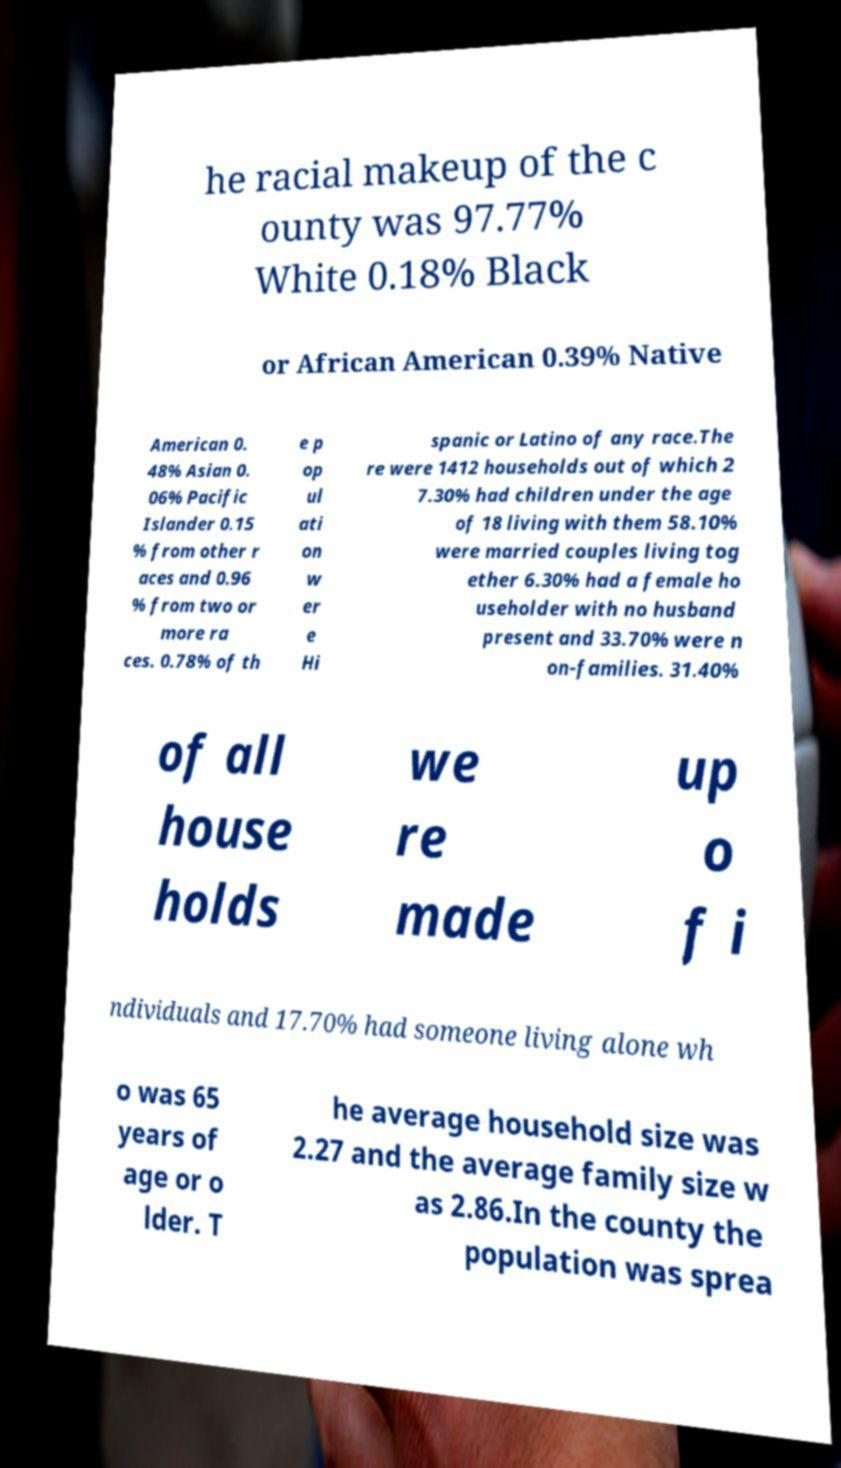Can you accurately transcribe the text from the provided image for me? he racial makeup of the c ounty was 97.77% White 0.18% Black or African American 0.39% Native American 0. 48% Asian 0. 06% Pacific Islander 0.15 % from other r aces and 0.96 % from two or more ra ces. 0.78% of th e p op ul ati on w er e Hi spanic or Latino of any race.The re were 1412 households out of which 2 7.30% had children under the age of 18 living with them 58.10% were married couples living tog ether 6.30% had a female ho useholder with no husband present and 33.70% were n on-families. 31.40% of all house holds we re made up o f i ndividuals and 17.70% had someone living alone wh o was 65 years of age or o lder. T he average household size was 2.27 and the average family size w as 2.86.In the county the population was sprea 